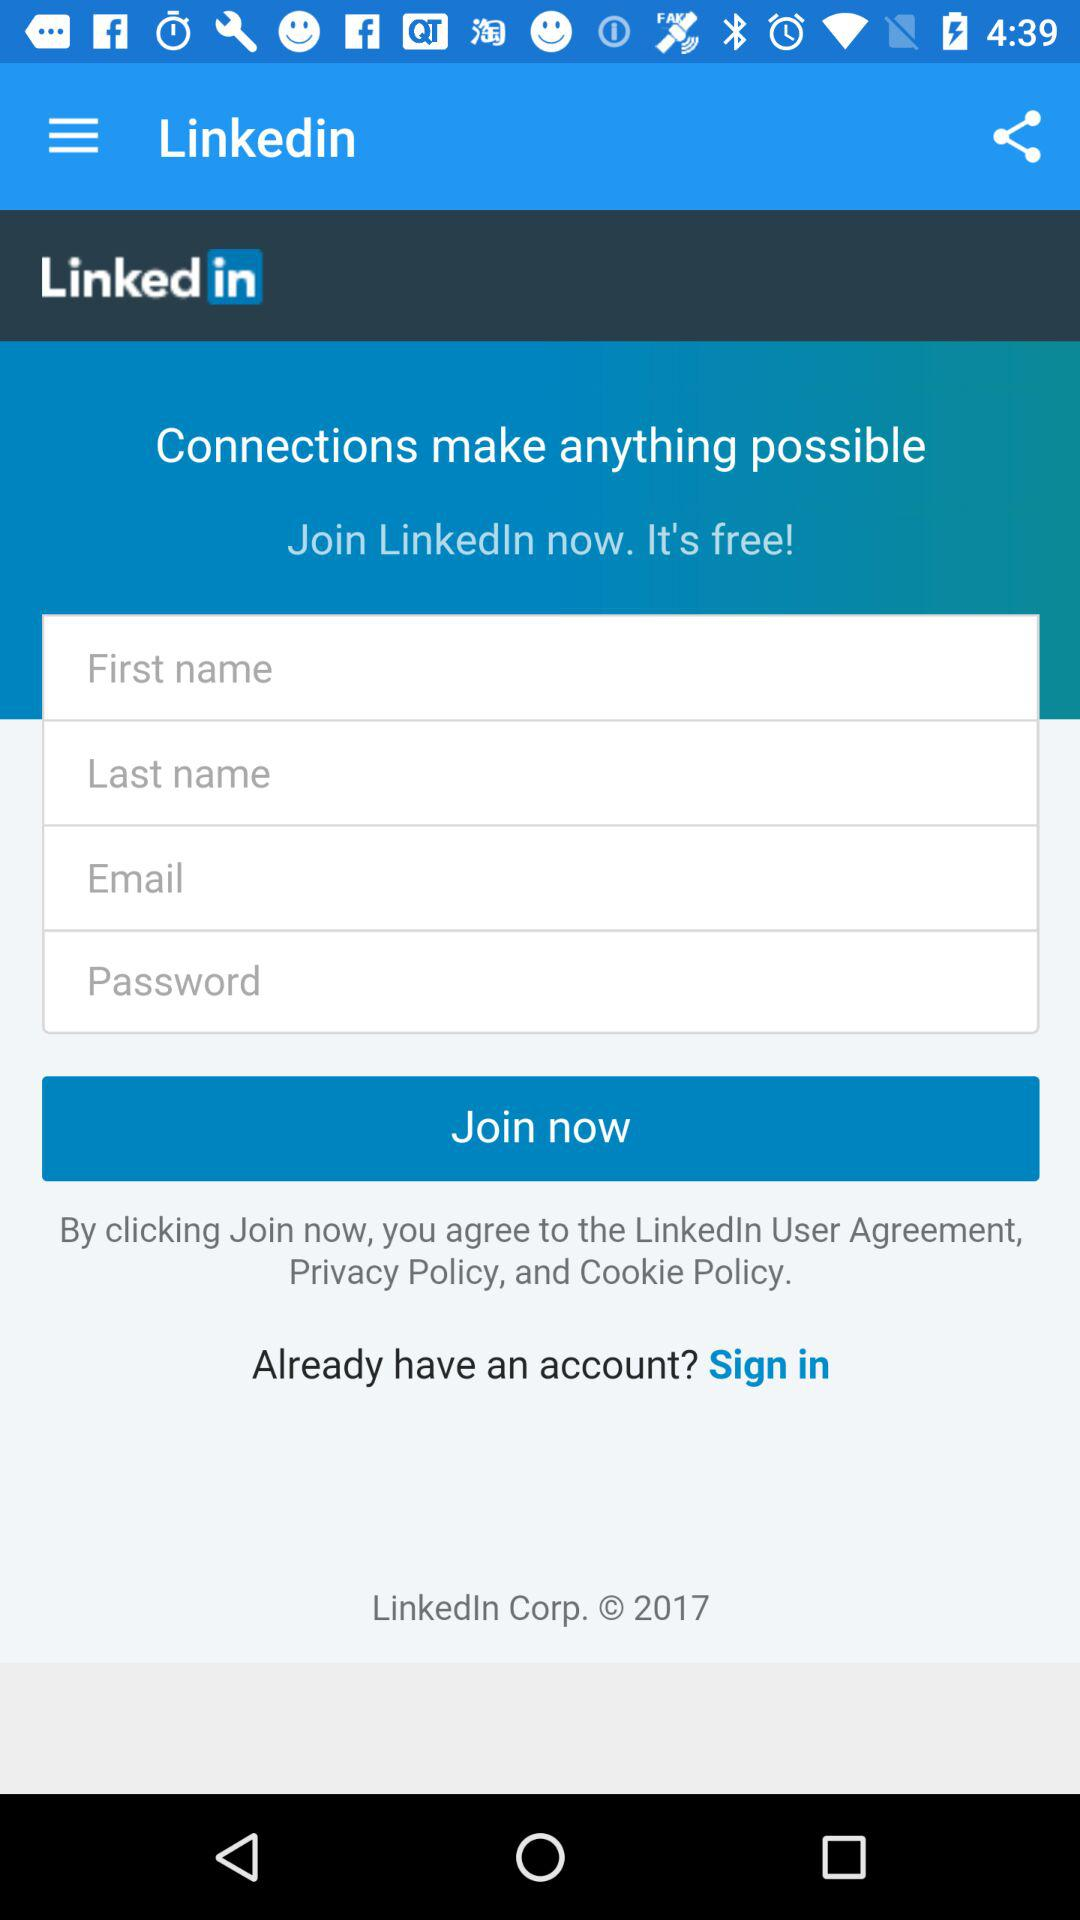How many characters are required to create a password?
When the provided information is insufficient, respond with <no answer>. <no answer> 